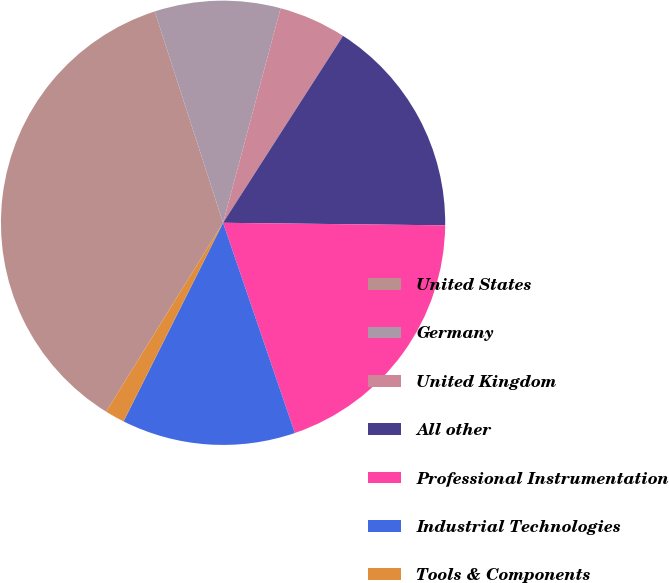Convert chart to OTSL. <chart><loc_0><loc_0><loc_500><loc_500><pie_chart><fcel>United States<fcel>Germany<fcel>United Kingdom<fcel>All other<fcel>Professional Instrumentation<fcel>Industrial Technologies<fcel>Tools & Components<nl><fcel>36.2%<fcel>9.15%<fcel>4.91%<fcel>16.1%<fcel>19.58%<fcel>12.63%<fcel>1.43%<nl></chart> 